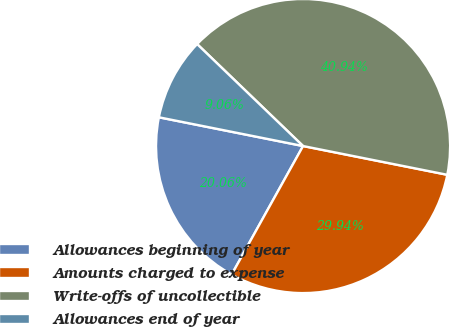Convert chart. <chart><loc_0><loc_0><loc_500><loc_500><pie_chart><fcel>Allowances beginning of year<fcel>Amounts charged to expense<fcel>Write-offs of uncollectible<fcel>Allowances end of year<nl><fcel>20.06%<fcel>29.94%<fcel>40.94%<fcel>9.06%<nl></chart> 